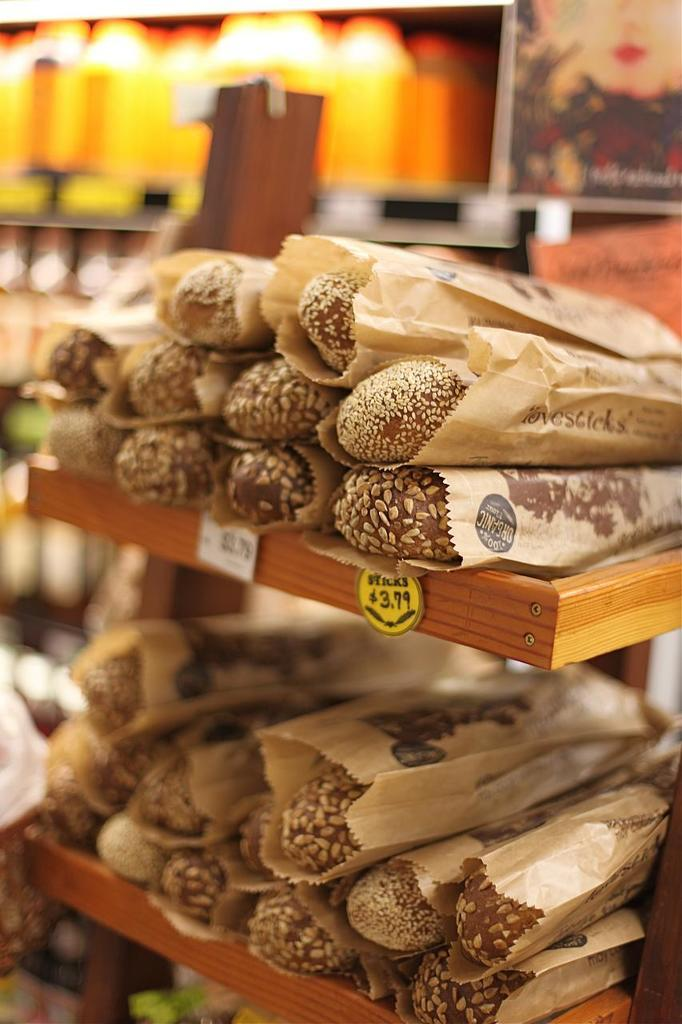What is present on the rack in the image? There are food items on a rack in the image. How can the food items be identified? The food items have name tags. What other object can be seen in the image? There is a photo frame in the image. Can you describe the background of the image? The background of the image is blurred. What type of shoes are visible in the image? There are no shoes present in the image. What kind of cheese is featured in the photo frame? There is no cheese present in the image, and there is no photo frame with a cheese image. 